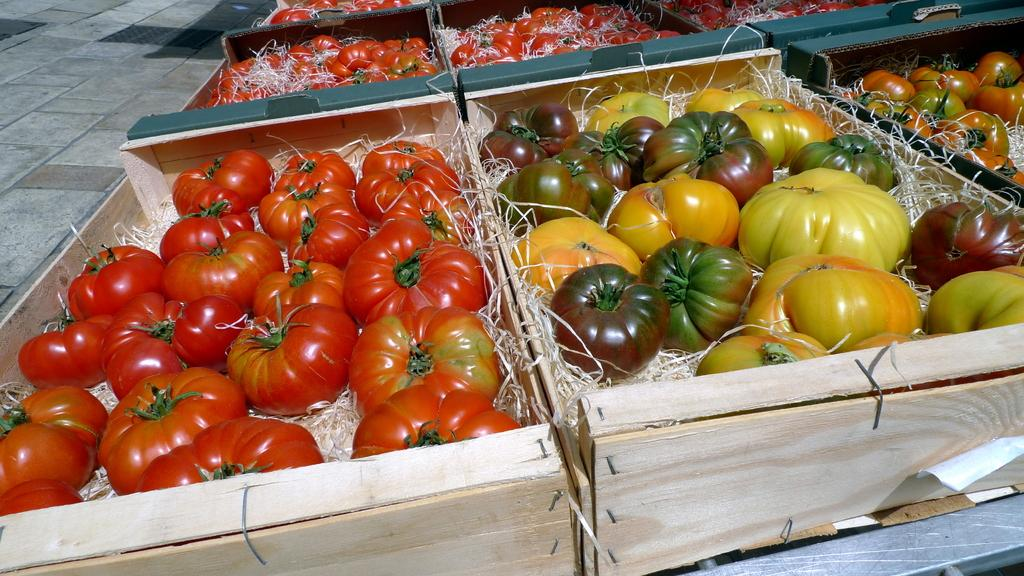What objects are present in the image? A: There are boxes and vegetables in the image. What surface can be seen beneath the objects? There is a floor visible in the image. Can you describe the type of objects in the image? The objects are boxes and vegetables. What type of yak can be seen interacting with the vegetables in the image? There is no yak present in the image; it only features boxes and vegetables. How does the hammer contribute to the arrangement of the vegetables in the image? There is no hammer present in the image, so it cannot contribute to the arrangement of the vegetables. 